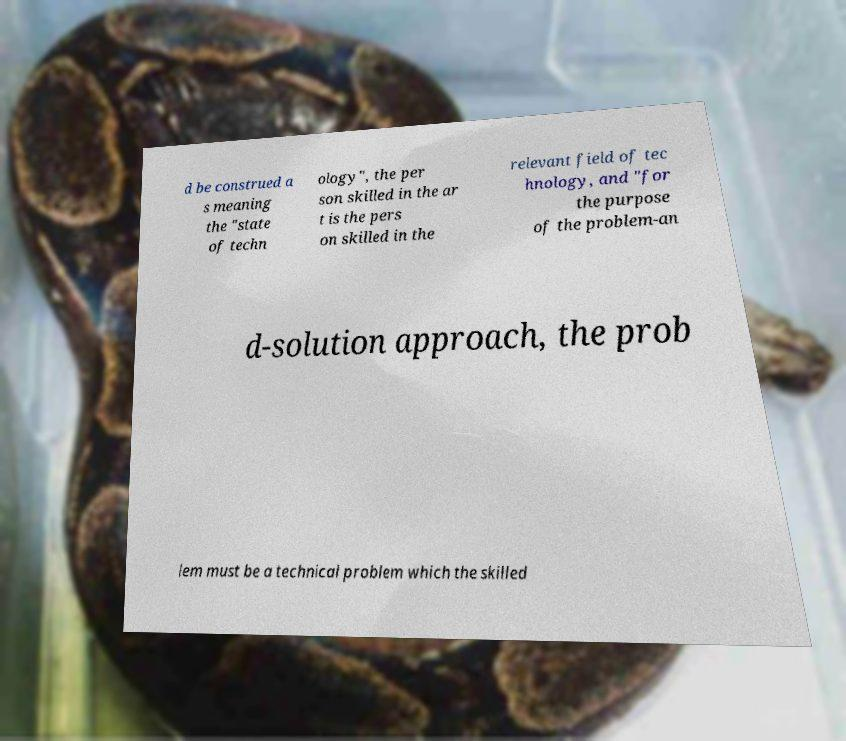There's text embedded in this image that I need extracted. Can you transcribe it verbatim? d be construed a s meaning the "state of techn ology", the per son skilled in the ar t is the pers on skilled in the relevant field of tec hnology, and "for the purpose of the problem-an d-solution approach, the prob lem must be a technical problem which the skilled 